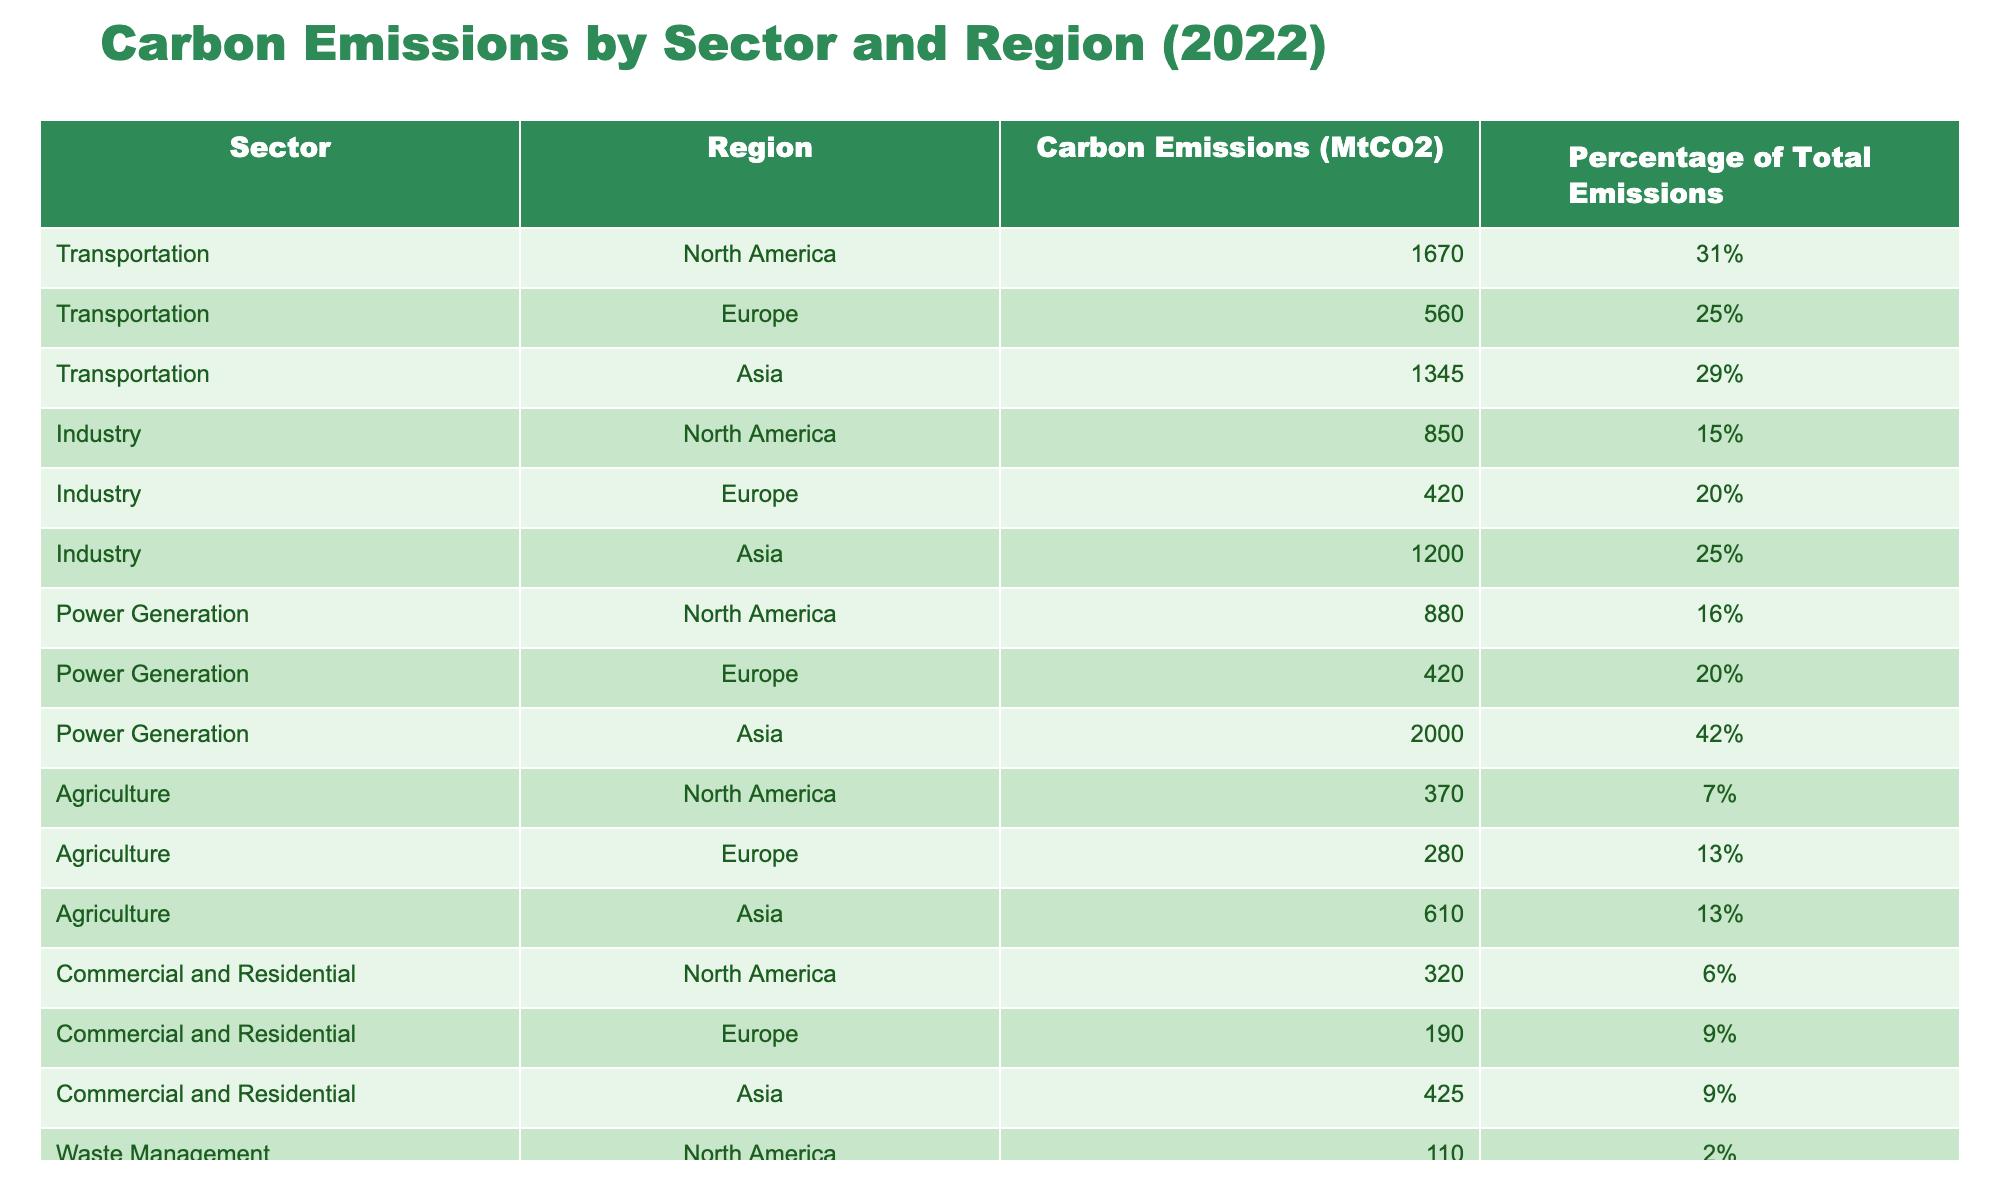What region has the highest carbon emissions from power generation? In the table, we look specifically at the "Power Generation" sector. The emissions for North America are 880 MtCO2, Europe is 420 MtCO2, and Asia is 2000 MtCO2. Since 2000 MtCO2 is higher than both North America and Europe, we determine that Asia has the highest emissions for that sector.
Answer: Asia What is the total carbon emissions from the transportation sector in Europe? The transportation sector emissions for Europe are listed as 560 MtCO2. Since this is a straightforward retrieval question, we can directly refer to that value in the table without further calculations.
Answer: 560 MtCO2 Which sector has the lowest total carbon emissions in North America? We need to analyze each sector's emissions in North America: Transportation (1670 MtCO2), Industry (850 MtCO2), Power Generation (880 MtCO2), Agriculture (370 MtCO2), Commercial and Residential (320 MtCO2), and Waste Management (110 MtCO2). The sector with the lowest emissions is Waste Management, with 110 MtCO2.
Answer: Waste Management What percentage of total emissions does agriculture account for in Asia? The table specifies that in Asia, the carbon emissions for Agriculture are 610 MtCO2, which accounts for 13% of total emissions. This direct retrieval from the table provides the required answer.
Answer: 13% If we combine the carbon emissions from transportation and agriculture in North America, what is the total? The transportation emissions in North America are 1670 MtCO2, and agriculture emissions are 370 MtCO2. We add these figures together: 1670 + 370 = 2040 MtCO2. Thus, the total is 2040 MtCO2.
Answer: 2040 MtCO2 Does Asia produce more carbon emissions from industry than Europe? In the table, Asia's industry emissions are stated as 1200 MtCO2, while Europe's industry emissions are 420 MtCO2. Since 1200 is greater than 420, we conclude that Asia does produce more emissions from industry than Europe.
Answer: Yes What is the average carbon emissions per sector for North America? For North America, the emissions data are as follows: Transportation (1670 MtCO2), Industry (850 MtCO2), Power Generation (880 MtCO2), Agriculture (370 MtCO2), Commercial and Residential (320 MtCO2), and Waste Management (110 MtCO2). We first sum these: 1670 + 850 + 880 + 370 + 320 + 110 = 4100 MtCO2. There are 6 sectors, so we divide the total emissions by the number of sectors: 4100 / 6 = approximately 683.33 MtCO2.
Answer: 683.33 MtCO2 What is the difference in carbon emissions between agriculture in North America and Asia? The emissions for agriculture in North America are 370 MtCO2, whereas for Asia, it is 610 MtCO2. To find the difference, we calculate: 610 - 370 = 240 MtCO2. Thus, Asia has 240 MtCO2 more emissions from agriculture than North America.
Answer: 240 MtCO2 What percentage of total emissions is contributed by the commercial and residential sector in Europe? The emissions for the commercial and residential sector in Europe are 190 MtCO2, representing 9% of the total emissions. This is a direct reference from the table, so we can simply report that value.
Answer: 9% 